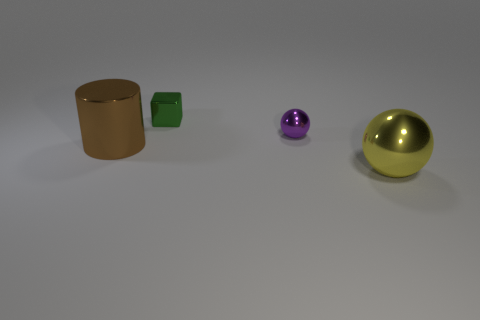Are there the same number of blocks that are behind the large brown metal cylinder and metallic spheres that are in front of the small purple object?
Offer a terse response. Yes. What is the material of the large object to the right of the tiny block?
Your response must be concise. Metal. Are there any other things that are the same size as the block?
Provide a succinct answer. Yes. Is the number of small green shiny cubes less than the number of blue cylinders?
Offer a terse response. No. There is a shiny thing that is both right of the green block and left of the yellow shiny thing; what is its shape?
Your response must be concise. Sphere. What number of big rubber cubes are there?
Give a very brief answer. 0. What material is the large thing behind the metal object right of the metal ball that is behind the brown metal cylinder?
Provide a short and direct response. Metal. What number of metal spheres are behind the big shiny thing that is on the right side of the green cube?
Keep it short and to the point. 1. There is a small metal thing that is the same shape as the large yellow metal object; what color is it?
Make the answer very short. Purple. Is the material of the tiny green object the same as the yellow object?
Your answer should be compact. Yes. 